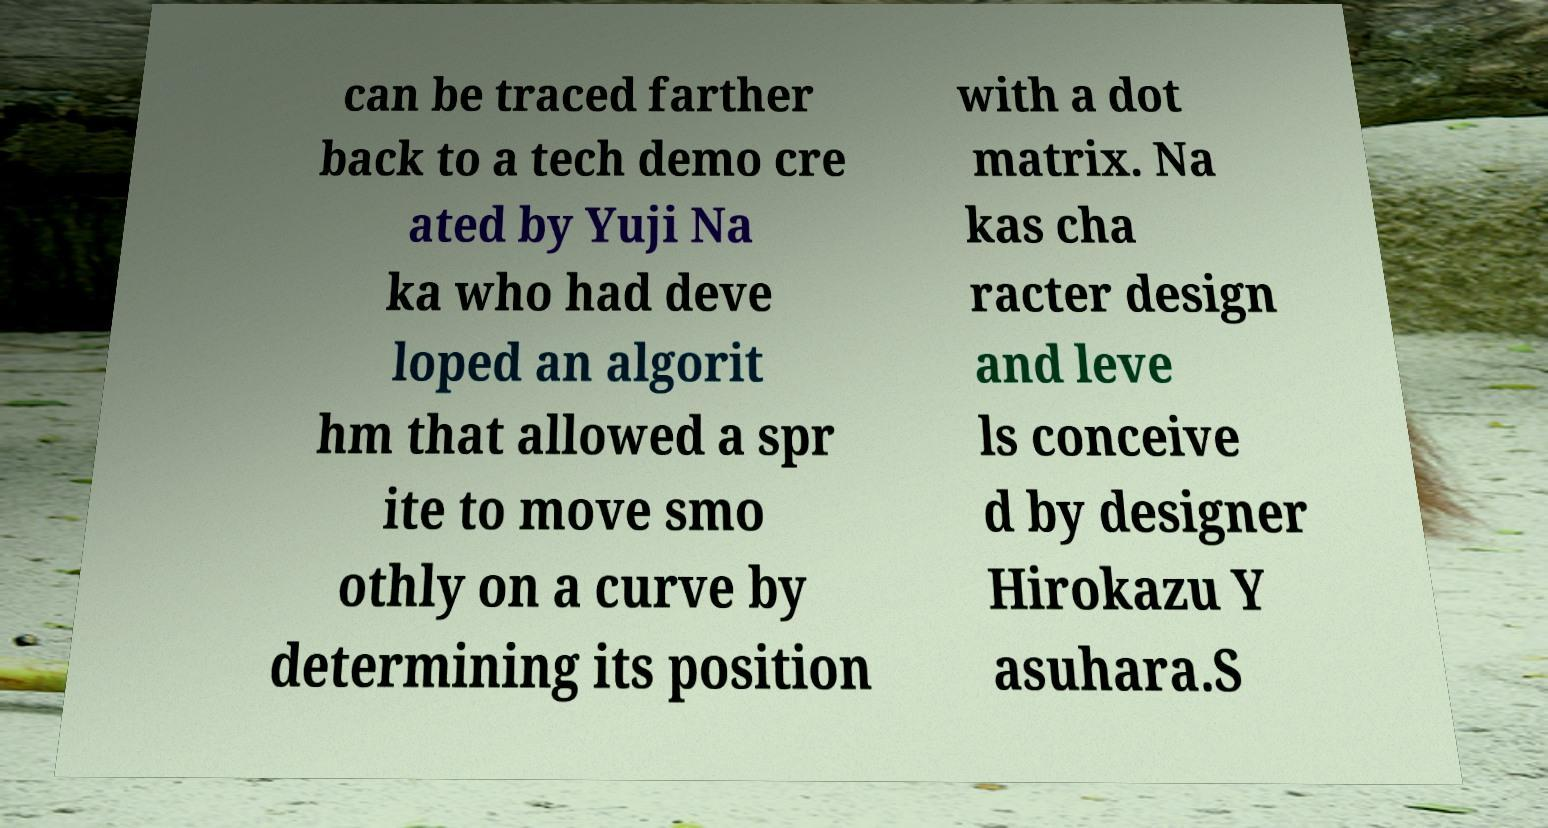Could you extract and type out the text from this image? can be traced farther back to a tech demo cre ated by Yuji Na ka who had deve loped an algorit hm that allowed a spr ite to move smo othly on a curve by determining its position with a dot matrix. Na kas cha racter design and leve ls conceive d by designer Hirokazu Y asuhara.S 